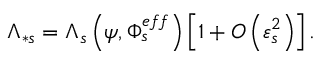<formula> <loc_0><loc_0><loc_500><loc_500>\Lambda _ { \ast s } = \Lambda _ { s } \left ( \psi , \Phi _ { s } ^ { e f f } \right ) \left [ 1 + O \left ( \varepsilon _ { s } ^ { 2 } \right ) \right ] .</formula> 